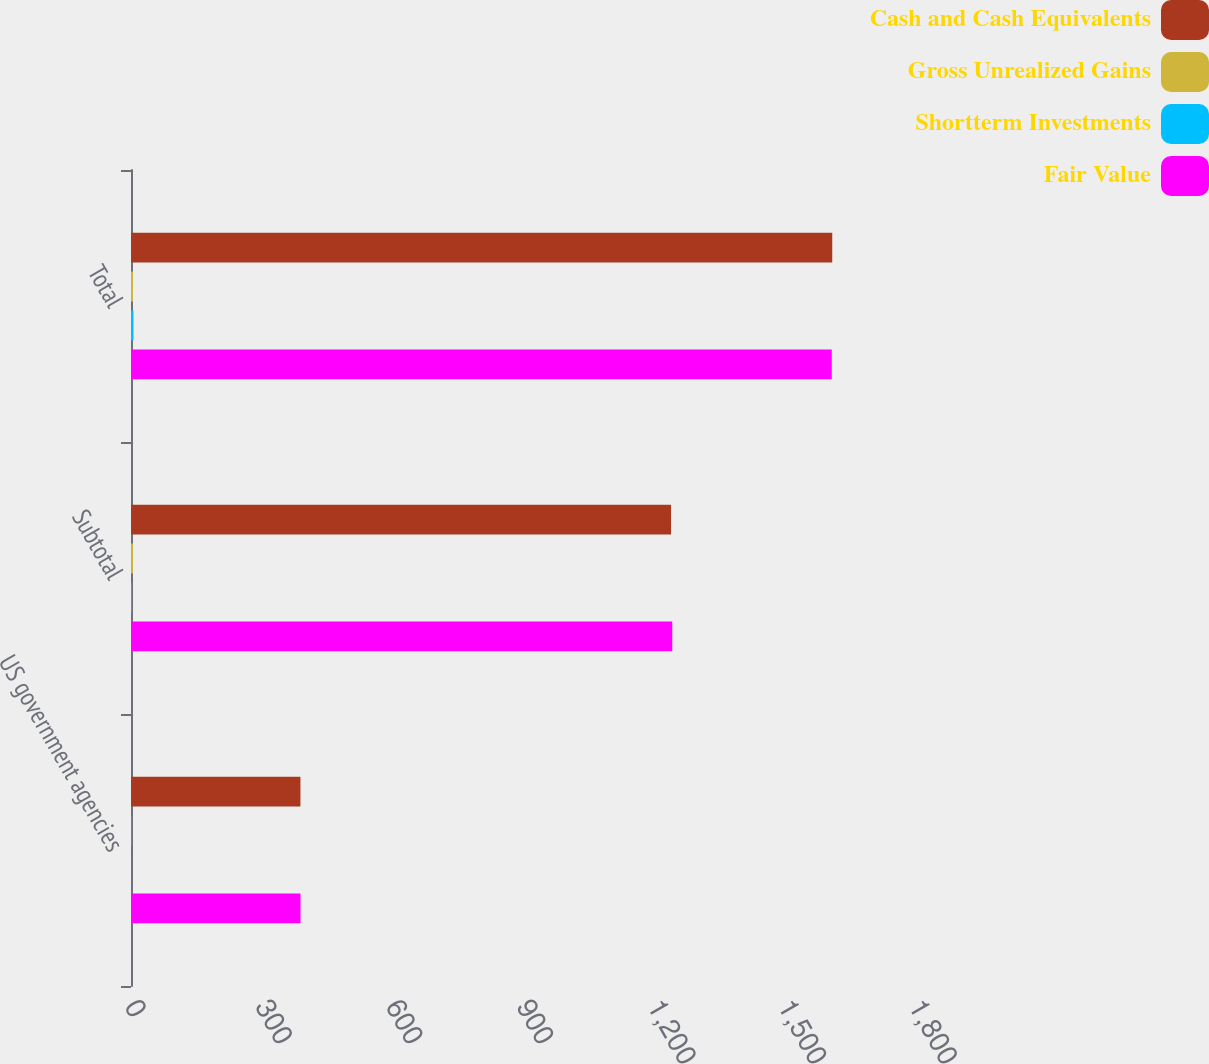<chart> <loc_0><loc_0><loc_500><loc_500><stacked_bar_chart><ecel><fcel>US government agencies<fcel>Subtotal<fcel>Total<nl><fcel>Cash and Cash Equivalents<fcel>389<fcel>1239.9<fcel>1610<nl><fcel>Gross Unrealized Gains<fcel>0.6<fcel>4.5<fcel>4.6<nl><fcel>Shortterm Investments<fcel>0.4<fcel>1.7<fcel>5.7<nl><fcel>Fair Value<fcel>389.2<fcel>1242.7<fcel>1608.9<nl></chart> 